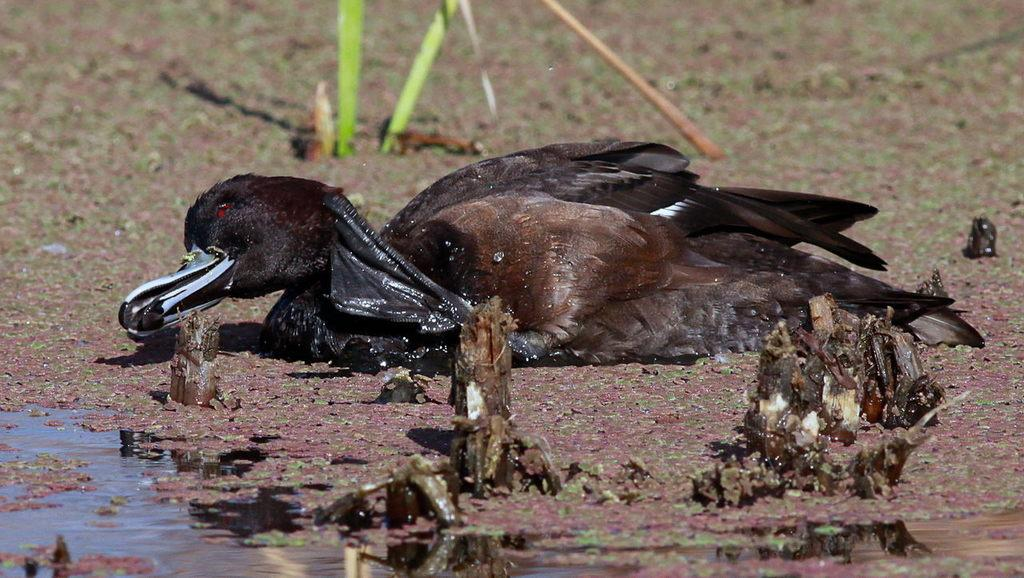What type of animal can be seen in the image? There is a bird in the image. What is the bird doing in the image? The bird is laying on a surface. What can be seen near the bird in the image? There is water visible near the bird. What colors can be observed on the bird in the image? The bird is black in color with some parts being brown. What type of curtain is hanging near the bird in the image? There is no curtain present in the image; it features a bird laying on a surface near water. 